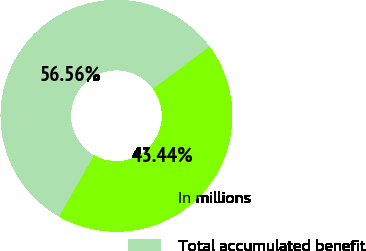Convert chart. <chart><loc_0><loc_0><loc_500><loc_500><pie_chart><fcel>In millions<fcel>Total accumulated benefit<nl><fcel>43.44%<fcel>56.56%<nl></chart> 